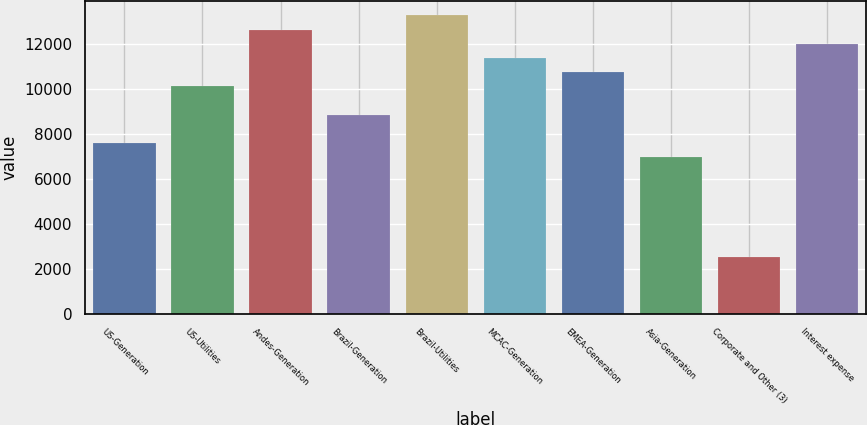<chart> <loc_0><loc_0><loc_500><loc_500><bar_chart><fcel>US-Generation<fcel>US-Utilities<fcel>Andes-Generation<fcel>Brazil-Generation<fcel>Brazil-Utilities<fcel>MCAC-Generation<fcel>EMEA-Generation<fcel>Asia-Generation<fcel>Corporate and Other (3)<fcel>Interest expense<nl><fcel>7603.8<fcel>10131.4<fcel>12659<fcel>8867.6<fcel>13290.9<fcel>11395.2<fcel>10763.3<fcel>6971.9<fcel>2548.6<fcel>12027.1<nl></chart> 